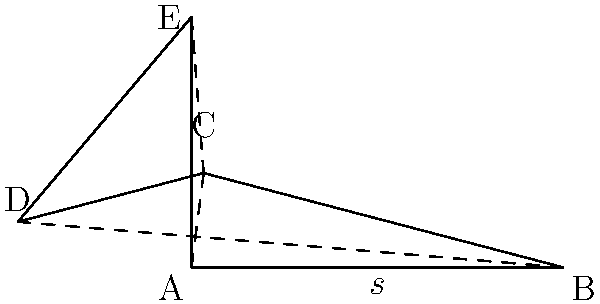A local artisan has crafted a pentagonal side table with intricate carved patterns. The table's top is a regular pentagon with side length $s = 5$ cm. Calculate the total edge length of the pentagonal tabletop, considering that the carved patterns add an additional 10% to each edge's length. To solve this problem, let's follow these steps:

1) First, we need to calculate the total edge length of a regular pentagon:
   - A regular pentagon has 5 equal sides
   - Total edge length = $5s$, where $s$ is the side length
   - Given $s = 5$ cm, the total edge length is $5 \times 5 = 25$ cm

2) Now, we need to account for the additional length due to the carved patterns:
   - The carved patterns add 10% to each edge's length
   - 10% increase means multiplying by 1.1
   - New total edge length = $25 \times 1.1 = 27.5$ cm

Therefore, the total edge length of the pentagonal tabletop with the carved patterns is 27.5 cm.

This calculation considers both the geometric properties of the pentagon and the artistic addition of the carved patterns, reflecting the craftsmanship and local artistry that went into creating this unique piece of furniture.
Answer: $27.5$ cm 